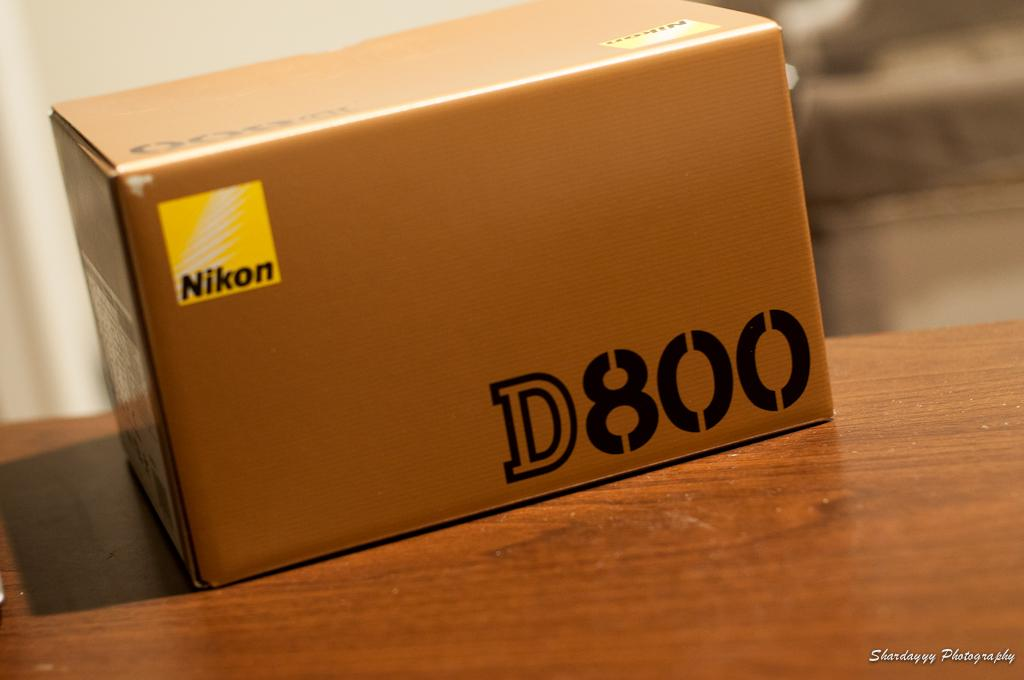What is located in the foreground of the image? There is a cardboard box in the foreground of the image. What is the cardboard box placed on? The cardboard box is on a wooden surface. Can you describe the background of the image? The background of the image is blurred. What type of pin is being used to hold the cardboard box to the stage in the image? There is no pin or stage present in the image; it only features a cardboard box on a wooden surface with a blurred background. 